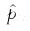<formula> <loc_0><loc_0><loc_500><loc_500>\hat { p } _ { x }</formula> 